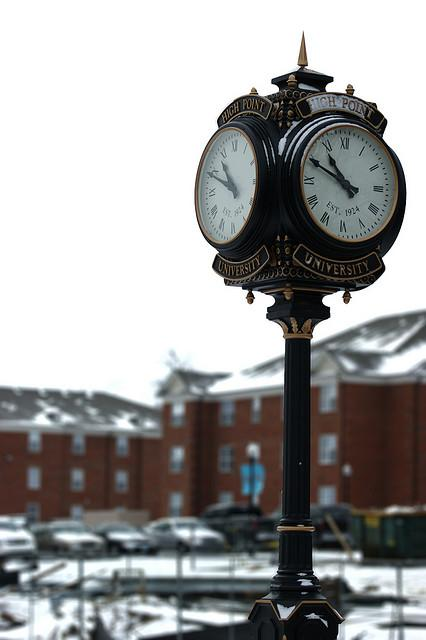This University is affiliated with what denomination? high point 